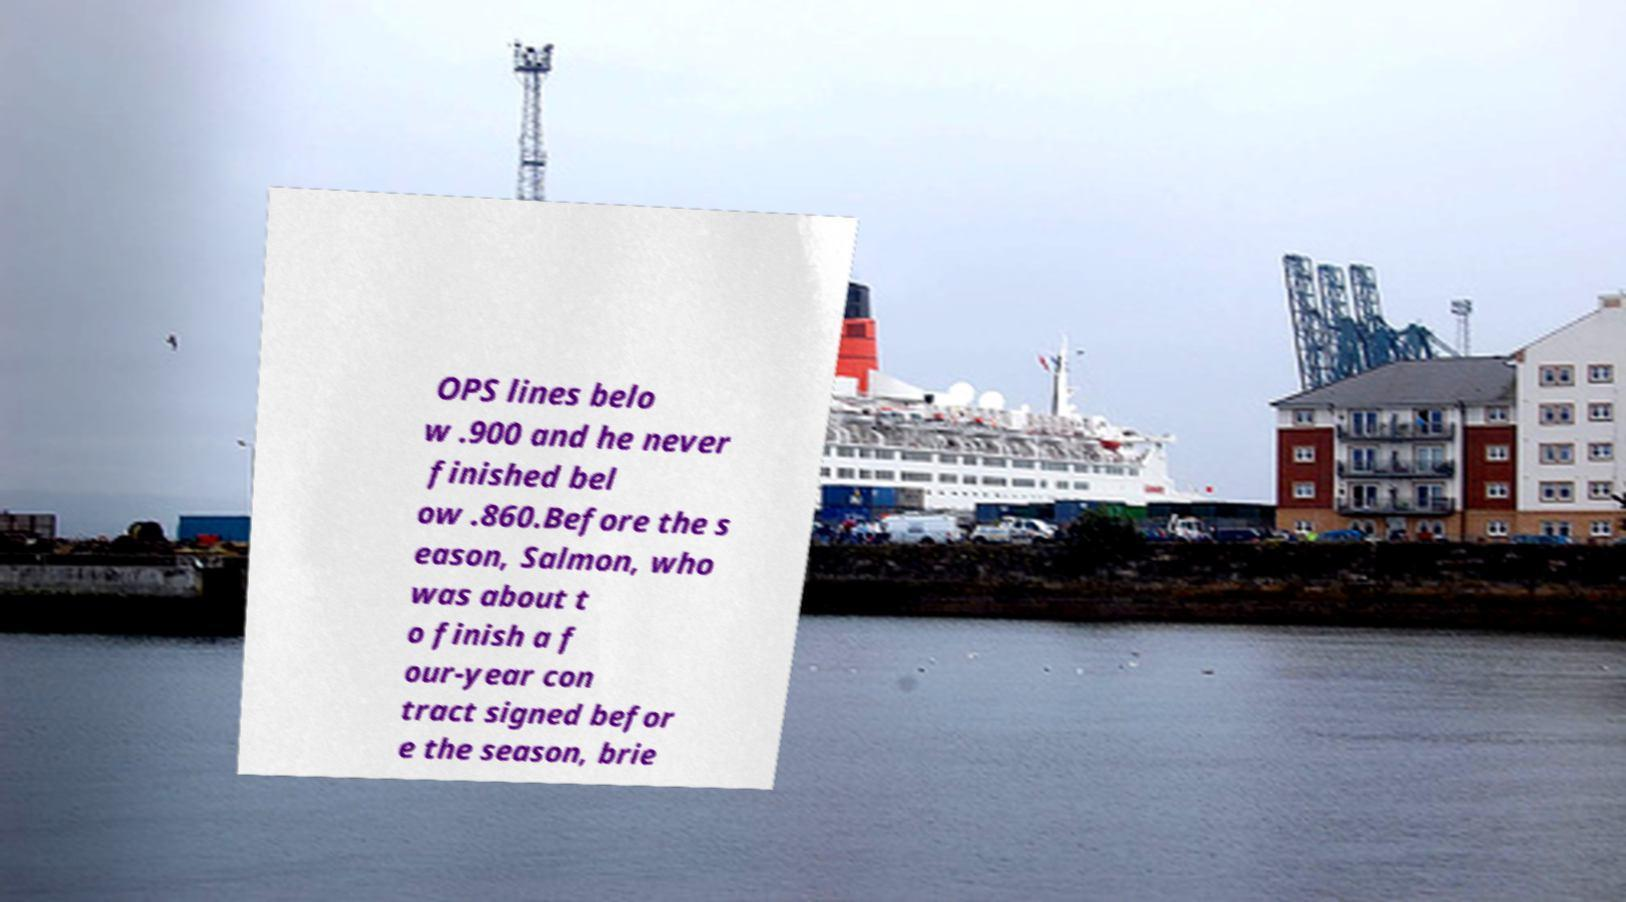For documentation purposes, I need the text within this image transcribed. Could you provide that? OPS lines belo w .900 and he never finished bel ow .860.Before the s eason, Salmon, who was about t o finish a f our-year con tract signed befor e the season, brie 